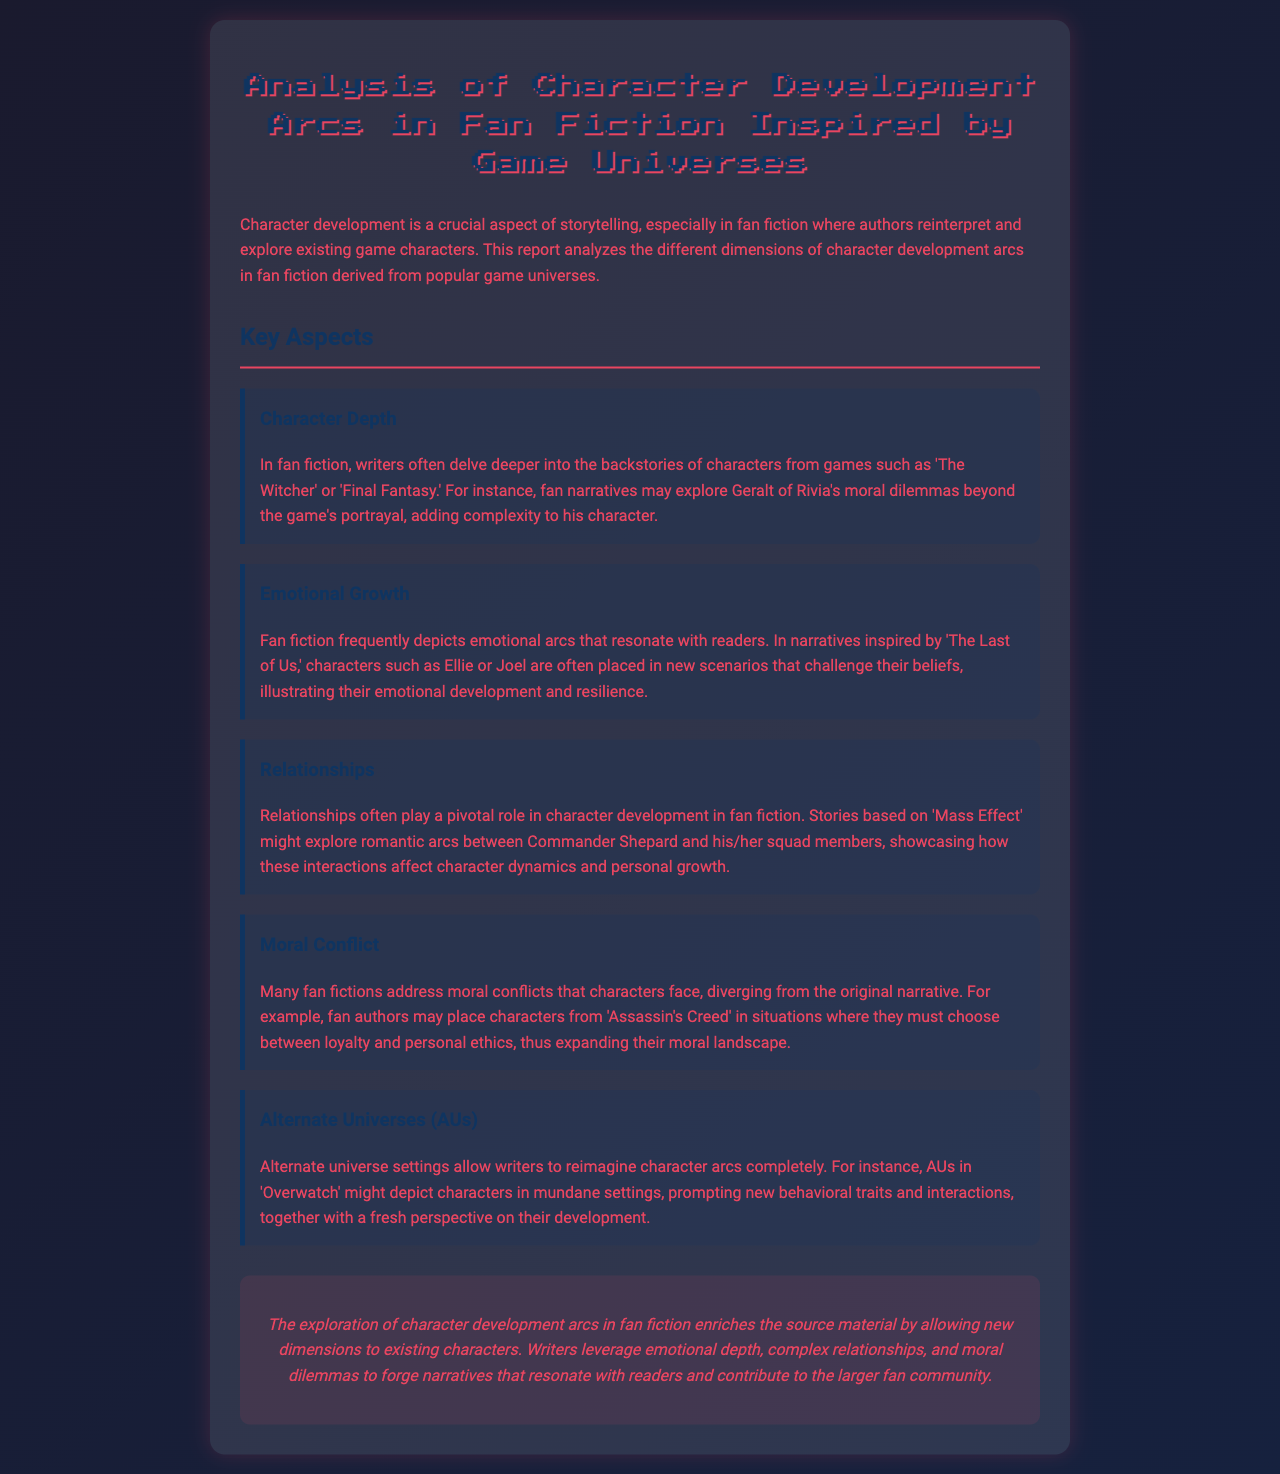What is the title of the report? The title of the report can be found at the top of the document under the heading.
Answer: Analysis of Character Development Arcs in Fan Fiction Inspired by Game Universes Which game character is mentioned in the context of moral dilemmas? The document references a specific character from 'The Witcher' to illustrate character depth involving moral dilemmas.
Answer: Geralt of Rivia What emotional arcs are depicted in narratives inspired by 'The Last of Us'? The report discusses how emotional growth is portrayed in fan fiction based on 'The Last of Us'.
Answer: Emotional development and resilience Which game is referenced regarding romantic arcs between characters? The document specifies a game known for its character relationships that may involve romantic arcs.
Answer: Mass Effect What is one narrative element frequently explored in alternate universes? The report addresses how alternate universe settings allow for complete reimaginings of character arcs and traits.
Answer: New behavioral traits What does the conclusion highlight about the impact of fan fiction on source material? The conclusion summarizes the overall effect of exploring character arcs in fan fiction on the original narratives.
Answer: Enriches the source material 